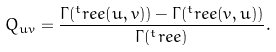Convert formula to latex. <formula><loc_0><loc_0><loc_500><loc_500>Q _ { u v } = \frac { \Gamma ( ^ { t } r e e ( u , v ) ) - \Gamma ( ^ { t } r e e ( v , u ) ) } { \Gamma ( ^ { t } r e e ) } .</formula> 